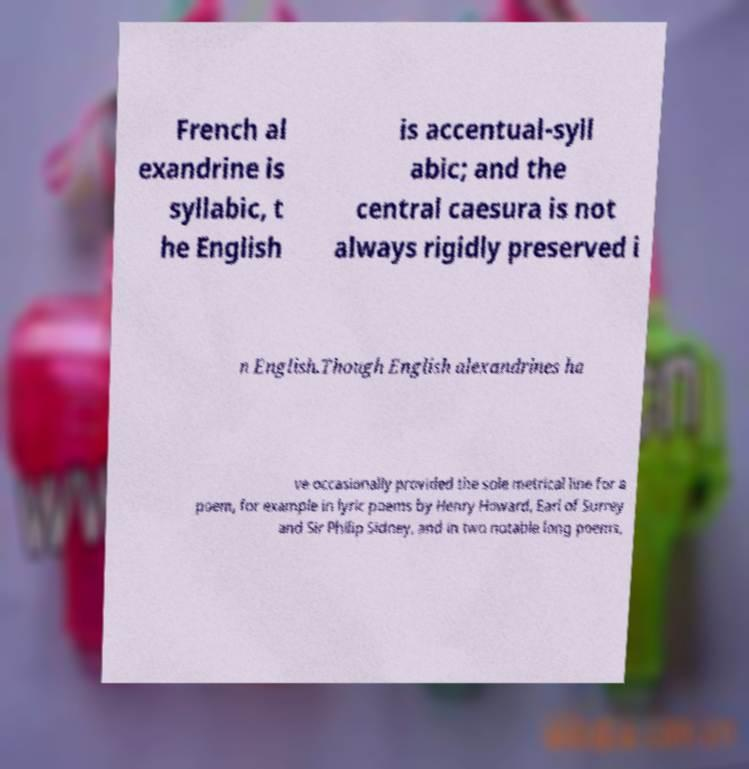Could you extract and type out the text from this image? French al exandrine is syllabic, t he English is accentual-syll abic; and the central caesura is not always rigidly preserved i n English.Though English alexandrines ha ve occasionally provided the sole metrical line for a poem, for example in lyric poems by Henry Howard, Earl of Surrey and Sir Philip Sidney, and in two notable long poems, 